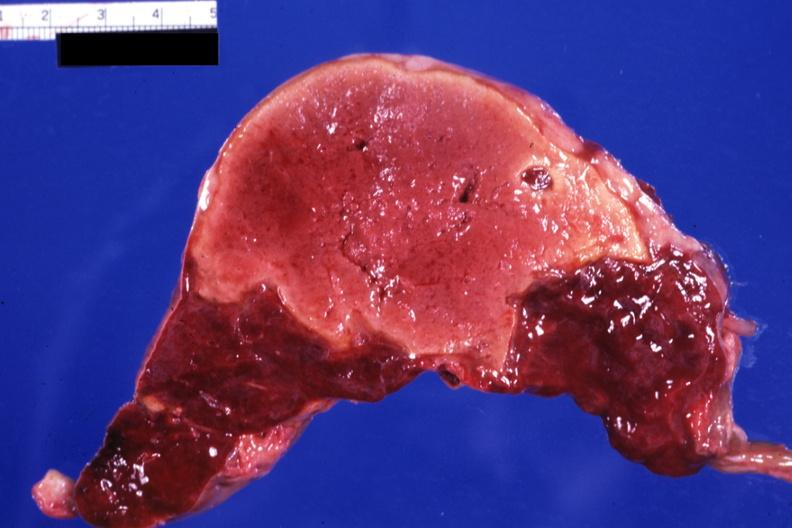where is this part in?
Answer the question using a single word or phrase. Spleen 